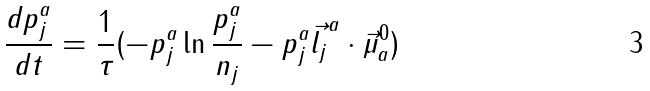<formula> <loc_0><loc_0><loc_500><loc_500>\frac { d p _ { j } ^ { a } } { d t } = \frac { 1 } { \tau } ( - p _ { j } ^ { a } \ln \frac { p _ { j } ^ { a } } { n _ { j } } - p _ { j } ^ { a } \vec { l _ { j } } ^ { a } \cdot \vec { \mu } _ { a } ^ { 0 } )</formula> 